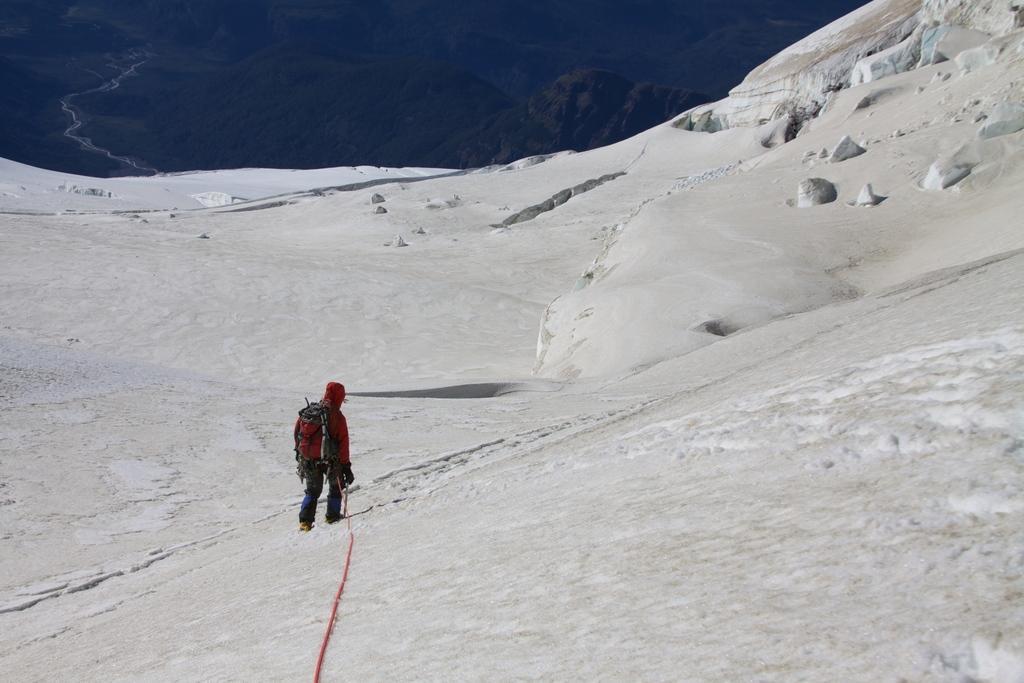In one or two sentences, can you explain what this image depicts? In the image in the center we can see one person standing and wearing backpack. In the background we can see snow. 